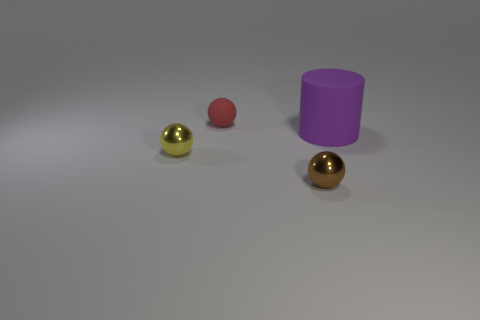Add 4 rubber balls. How many objects exist? 8 Subtract all spheres. How many objects are left? 1 Add 2 large purple matte cylinders. How many large purple matte cylinders exist? 3 Subtract 0 brown cylinders. How many objects are left? 4 Subtract all tiny green rubber objects. Subtract all tiny red balls. How many objects are left? 3 Add 4 cylinders. How many cylinders are left? 5 